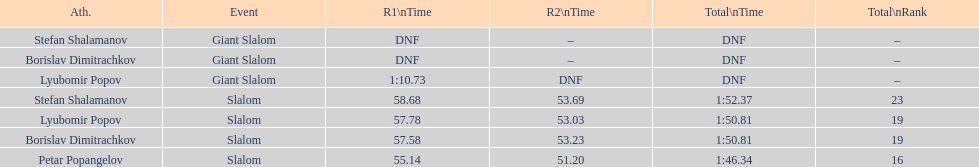Who has the highest rank? Petar Popangelov. 